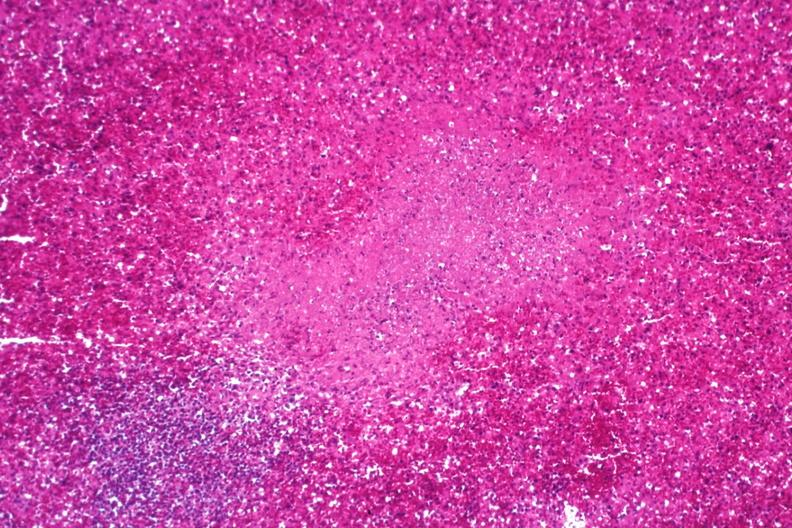what is present?
Answer the question using a single word or phrase. Hematologic 